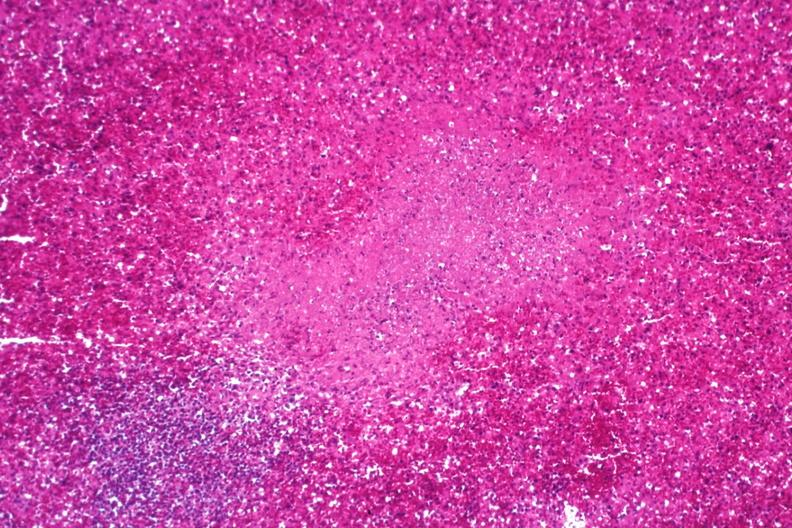what is present?
Answer the question using a single word or phrase. Hematologic 